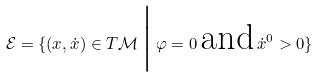Convert formula to latex. <formula><loc_0><loc_0><loc_500><loc_500>\mathcal { E } = \{ ( x , \dot { x } ) \in T \mathcal { M } \, \Big | \, \varphi = 0 \, \text {and} \, \dot { x } ^ { 0 } > 0 \}</formula> 